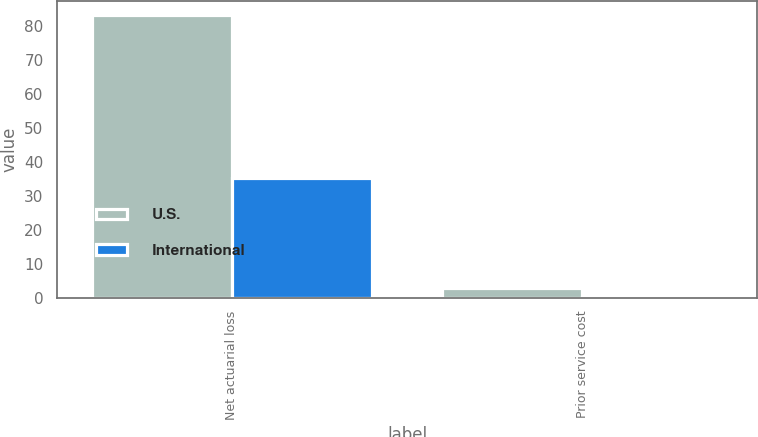Convert chart. <chart><loc_0><loc_0><loc_500><loc_500><stacked_bar_chart><ecel><fcel>Net actuarial loss<fcel>Prior service cost<nl><fcel>U.S.<fcel>83.2<fcel>2.8<nl><fcel>International<fcel>35.1<fcel>0.1<nl></chart> 